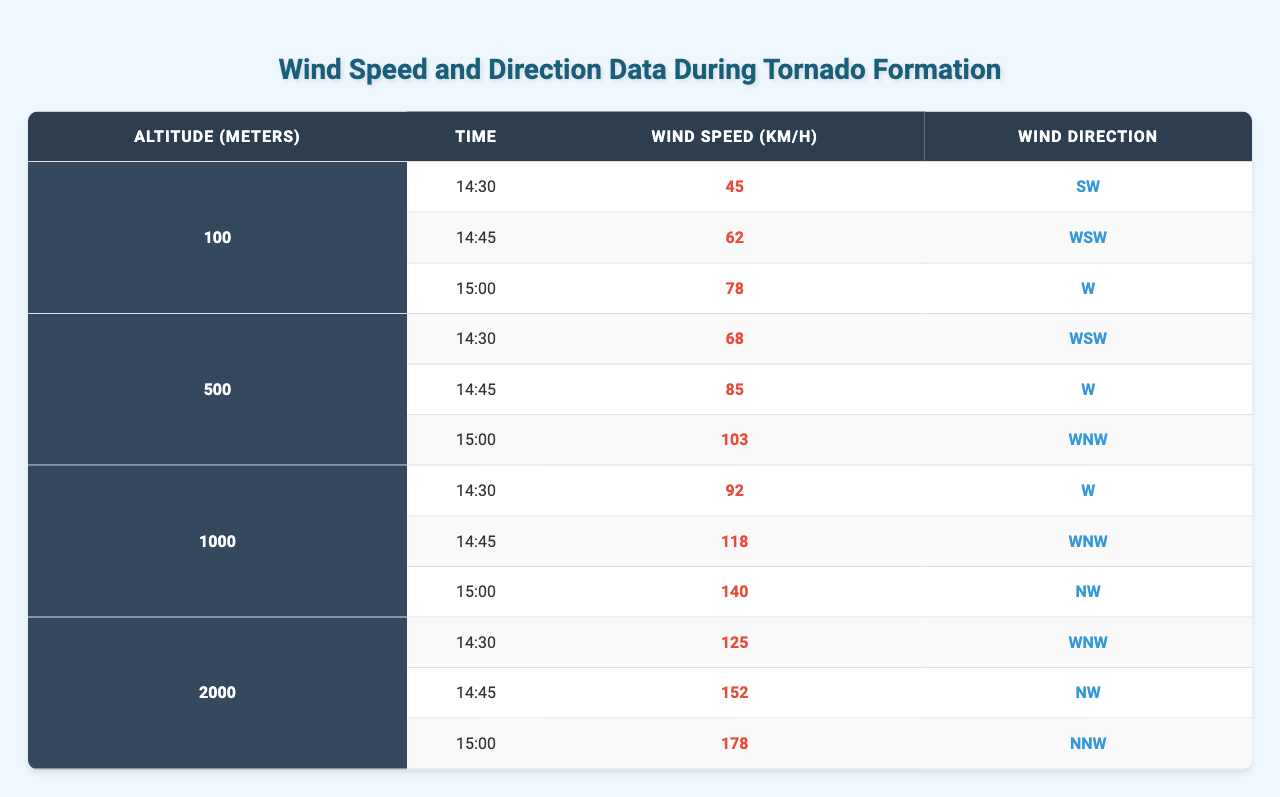What was the wind speed at 500 meters altitude at 15:00? According to the table, the wind speed at 500 meters altitude at 15:00 is recorded as 103 km/h.
Answer: 103 km/h What is the maximum wind speed recorded at 1000 meters altitude? The highest wind speed at 1000 meters is observed at 15:00, which is 140 km/h.
Answer: 140 km/h Which measurement time had the highest wind speed at 2000 meters altitude? At 15:00, the highest wind speed at 2000 meters altitude was 178 km/h.
Answer: 15:00 What is the average wind speed recorded at 100 meters altitude during the measurements? To find the average at 100 meters, sum the speeds: (45 + 62 + 78) = 185 km/h. Divide by 3 measurements: 185 / 3 = 61.67 km/h.
Answer: 61.67 km/h At which altitude did the wind speed first exceed 100 km/h, and at what time? The wind speed first exceeds 100 km/h at 500 meters at 15:00, with a speed of 103 km/h.
Answer: 500 meters at 15:00 Is there a measurement time where all recorded wind directions were from the west? No, at none of the times is the recorded wind direction exclusively from the west.
Answer: No Which altitude had the most consistent wind direction and what was it? The altitude of 1000 meters showed consistent wind direction towards the west and northwest, indicating predominantly W and WNW directions.
Answer: W and WNW How does the wind speed change from 14:30 to 15:00 at 1000 meters? At 1000 meters, the wind speed increases from 92 km/h at 14:30 to 140 km/h at 15:00, an increase of 48 km/h.
Answer: Increase of 48 km/h Is the wind direction at 2000 meters altitude clockwise or counterclockwise from 14:30 to 15:00? The wind direction went from WNW to NNW, indicating a counterclockwise direction.
Answer: Counterclockwise What was the difference in wind speed between 500 meters at 14:45 and 2000 meters at 14:30? The wind speed at 500m at 14:45 is 85 km/h, while at 2000m at 14:30 it is 125 km/h, showing a difference of 40 km/h.
Answer: 40 km/h 